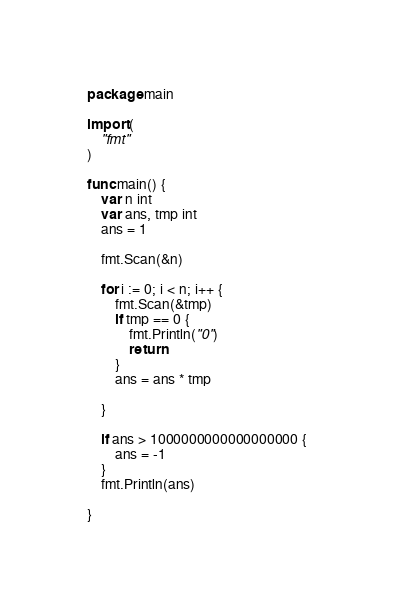Convert code to text. <code><loc_0><loc_0><loc_500><loc_500><_Go_>package main

import (
	"fmt"
)

func main() {
	var n int
	var ans, tmp int
	ans = 1

	fmt.Scan(&n)

	for i := 0; i < n; i++ {
		fmt.Scan(&tmp)
		if tmp == 0 {
			fmt.Println("0")
			return
		}
		ans = ans * tmp

	}

	if ans > 1000000000000000000 {
		ans = -1
	}
	fmt.Println(ans)

}
</code> 